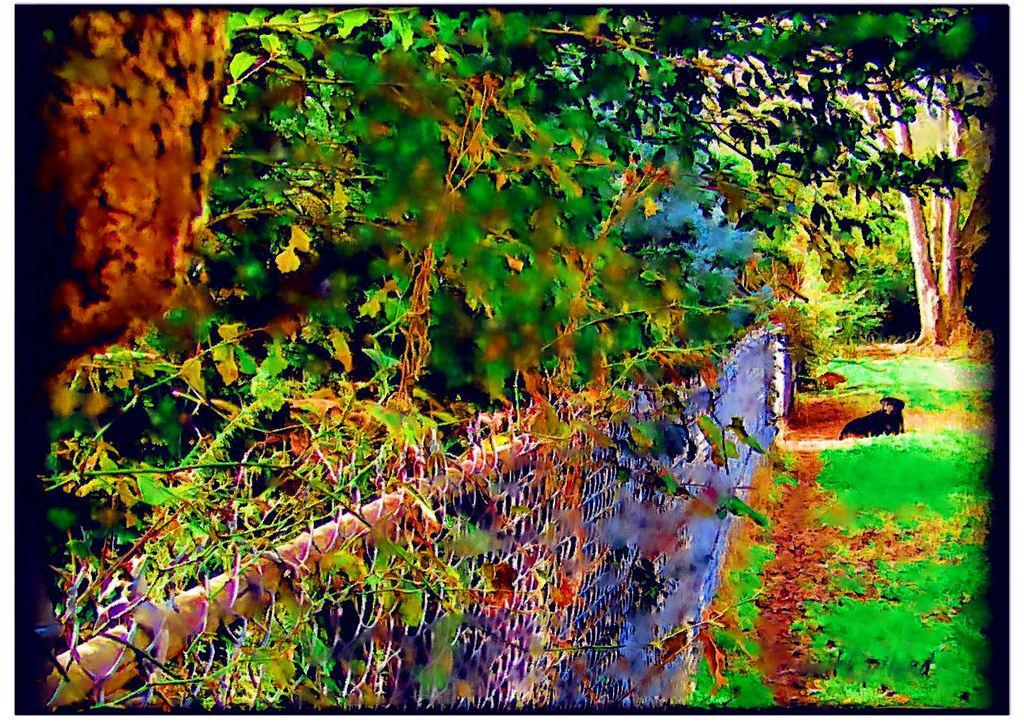Please provide a concise description of this image. In this picture I can see trees and grass on the ground. I can see metal fence and a dog. 